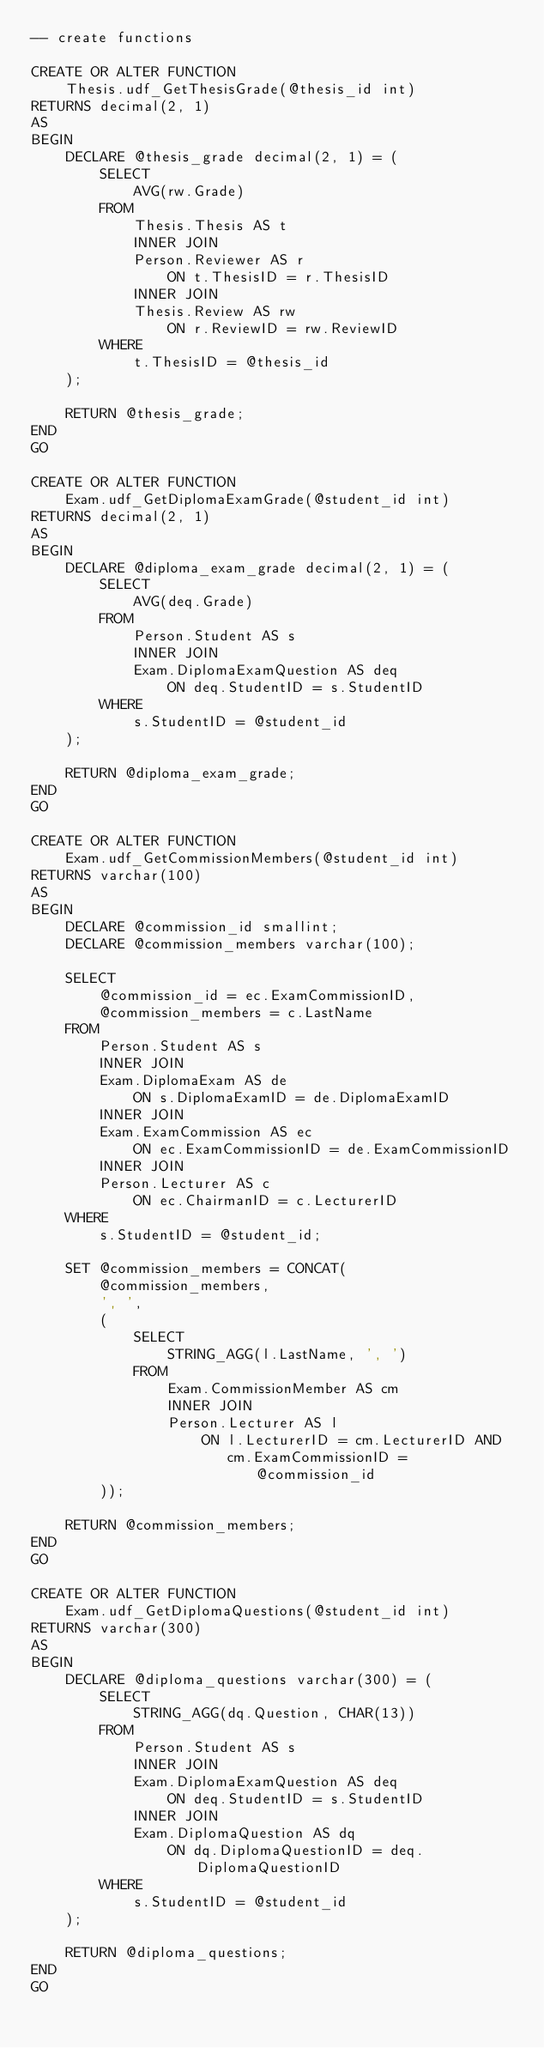Convert code to text. <code><loc_0><loc_0><loc_500><loc_500><_SQL_>-- create functions

CREATE OR ALTER FUNCTION
    Thesis.udf_GetThesisGrade(@thesis_id int)
RETURNS decimal(2, 1)
AS
BEGIN
    DECLARE @thesis_grade decimal(2, 1) = (
        SELECT
            AVG(rw.Grade)
        FROM
            Thesis.Thesis AS t
            INNER JOIN
            Person.Reviewer AS r
                ON t.ThesisID = r.ThesisID
            INNER JOIN
            Thesis.Review AS rw
                ON r.ReviewID = rw.ReviewID
        WHERE
            t.ThesisID = @thesis_id
    );

    RETURN @thesis_grade;
END
GO

CREATE OR ALTER FUNCTION
    Exam.udf_GetDiplomaExamGrade(@student_id int)
RETURNS decimal(2, 1)
AS
BEGIN
    DECLARE @diploma_exam_grade decimal(2, 1) = (
        SELECT
            AVG(deq.Grade)
        FROM
            Person.Student AS s
            INNER JOIN
            Exam.DiplomaExamQuestion AS deq
                ON deq.StudentID = s.StudentID
        WHERE
            s.StudentID = @student_id
    );

    RETURN @diploma_exam_grade;
END
GO

CREATE OR ALTER FUNCTION
    Exam.udf_GetCommissionMembers(@student_id int)
RETURNS varchar(100)
AS
BEGIN
    DECLARE @commission_id smallint;
    DECLARE @commission_members varchar(100);

    SELECT
        @commission_id = ec.ExamCommissionID,
        @commission_members = c.LastName
    FROM
        Person.Student AS s
        INNER JOIN
        Exam.DiplomaExam AS de
            ON s.DiplomaExamID = de.DiplomaExamID
        INNER JOIN
        Exam.ExamCommission AS ec
            ON ec.ExamCommissionID = de.ExamCommissionID
        INNER JOIN
        Person.Lecturer AS c
            ON ec.ChairmanID = c.LecturerID
    WHERE
        s.StudentID = @student_id;

    SET @commission_members = CONCAT(
        @commission_members,
        ', ',
        (
            SELECT
                STRING_AGG(l.LastName, ', ')
            FROM
                Exam.CommissionMember AS cm
                INNER JOIN
                Person.Lecturer AS l
                    ON l.LecturerID = cm.LecturerID AND
                       cm.ExamCommissionID = @commission_id
        ));

    RETURN @commission_members;
END
GO

CREATE OR ALTER FUNCTION
    Exam.udf_GetDiplomaQuestions(@student_id int)
RETURNS varchar(300)
AS
BEGIN
    DECLARE @diploma_questions varchar(300) = (
        SELECT
            STRING_AGG(dq.Question, CHAR(13))
        FROM
            Person.Student AS s
            INNER JOIN
            Exam.DiplomaExamQuestion AS deq
                ON deq.StudentID = s.StudentID
            INNER JOIN
            Exam.DiplomaQuestion AS dq
                ON dq.DiplomaQuestionID = deq.DiplomaQuestionID
        WHERE
            s.StudentID = @student_id
    );

    RETURN @diploma_questions;
END
GO
</code> 